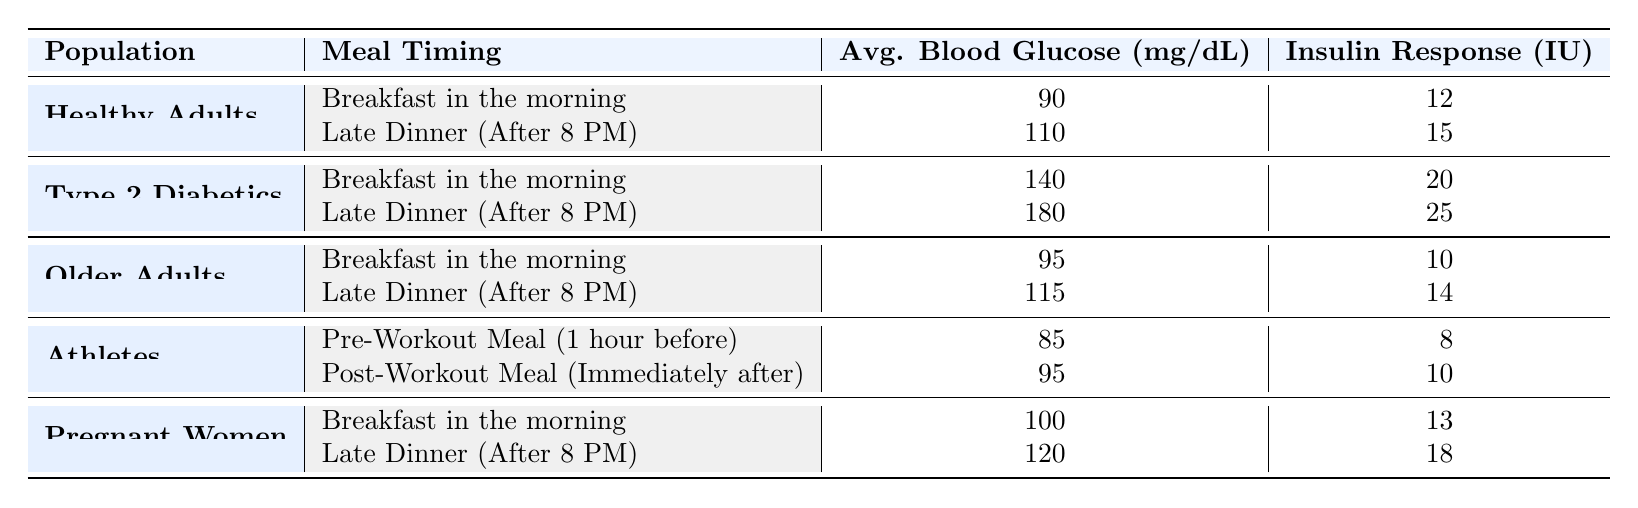What is the average blood glucose level for Type 2 Diabetics after a late dinner? The average blood glucose level for Type 2 Diabetics after a late dinner is provided in the table and is listed as 180 mg/dL.
Answer: 180 mg/dL Which population has the lowest average blood glucose level for their pre-workout meal? The table shows that Athletes have a pre-workout meal average blood glucose level of 85 mg/dL, which is the lowest compared to other populations listed.
Answer: 85 mg/dL Is the insulin response for older adults higher after a late dinner than for pregnant women after breakfast? The table shows that the insulin response for older adults after a late dinner is 14 IU, while for pregnant women after breakfast it is 13 IU. Therefore, the response for older adults is indeed higher after a late dinner.
Answer: Yes What is the difference in average blood glucose levels for Healthy Adults between breakfast and late dinner? Looking at the table, Healthy Adults have an average blood glucose level of 90 mg/dL for breakfast and 110 mg/dL for a late dinner. Thus, the difference is 110 - 90 = 20 mg/dL.
Answer: 20 mg/dL Do Type 2 Diabetics have a higher insulin response after a late dinner than Healthy Adults after breakfast? According to the table, Type 2 Diabetics have an insulin response of 25 IU after a late dinner, while Healthy Adults have a response of 12 IU after breakfast. Since 25 IU is greater than 12 IU, the statement is true.
Answer: Yes What is the average insulin response for Athletes across their pre-workout and post-workout meals? To find this average, look at the insulin responses for Athletes: pre-workout is 8 IU and post-workout is 10 IU. Adding these values, 8 + 10 = 18 IU, divides by 2 (since there are 2 responses), resulting in 18/2 = 9 IU as the average.
Answer: 9 IU Which meal timing corresponds to the highest average blood glucose level in the data? The table indicates that the highest recorded average blood glucose level is 180 mg/dL for Type 2 Diabetics after a late dinner, making this the meal timing with the highest level.
Answer: Late Dinner (After 8 PM) Has the average blood glucose level for Pregnant Women after a late dinner been recorded as 130 mg/dL? The table specifies that the average blood glucose level for Pregnant Women after a late dinner is actually 120 mg/dL, not 130 mg/dL, making the statement false.
Answer: No 